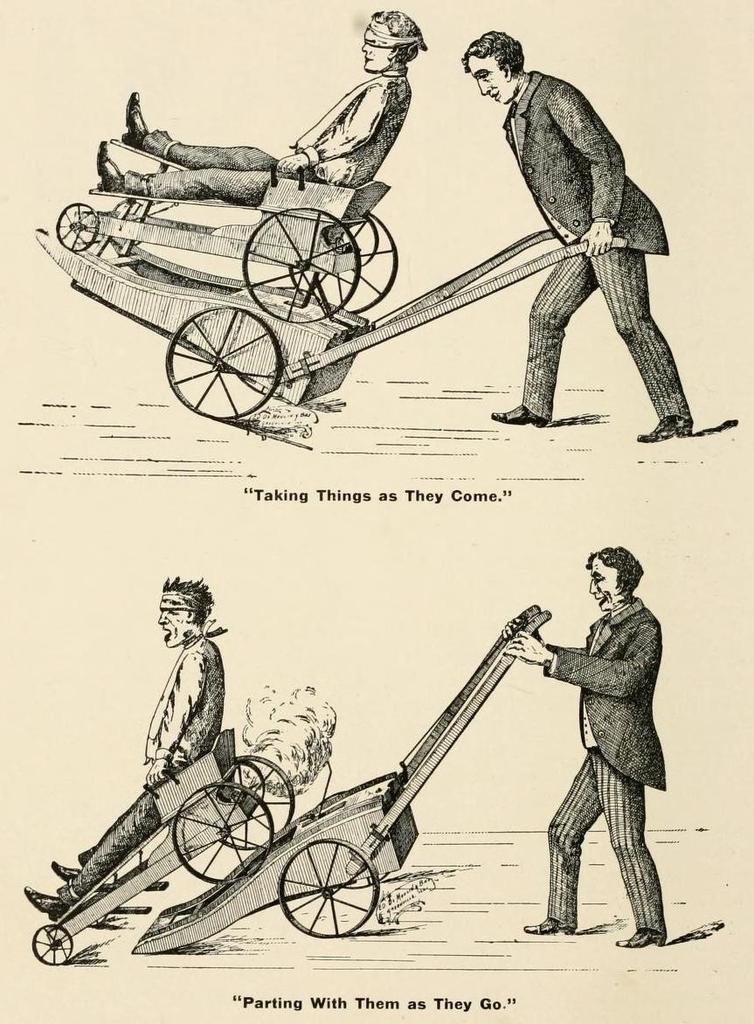Please provide a concise description of this image. Here we can see two persons. One person is on the cart and another person is holding a cart with his hand. Under these images we can see text. 